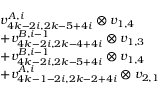<formula> <loc_0><loc_0><loc_500><loc_500>\begin{array} { r l } & { v _ { 4 k - 2 i , 2 k - 5 + 4 i } ^ { A , i } \otimes v _ { 1 , 4 } } \\ & { + v _ { 4 k - 2 i , 2 k - 4 + 4 i } ^ { B , i - 1 } \otimes v _ { 1 , 3 } } \\ & { + v _ { 4 k - 2 i , 2 k - 5 + 4 i } ^ { B , i - 1 } \otimes v _ { 1 , 4 } } \\ & { + v _ { 4 k - 1 - 2 i , 2 k - 2 + 4 i } ^ { A , i } \otimes v _ { 2 , 1 } } \end{array}</formula> 